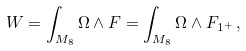Convert formula to latex. <formula><loc_0><loc_0><loc_500><loc_500>W = \int _ { M _ { 8 } } \Omega \wedge F = \int _ { M _ { 8 } } \Omega \wedge F _ { { 1 } ^ { + } } \, ,</formula> 